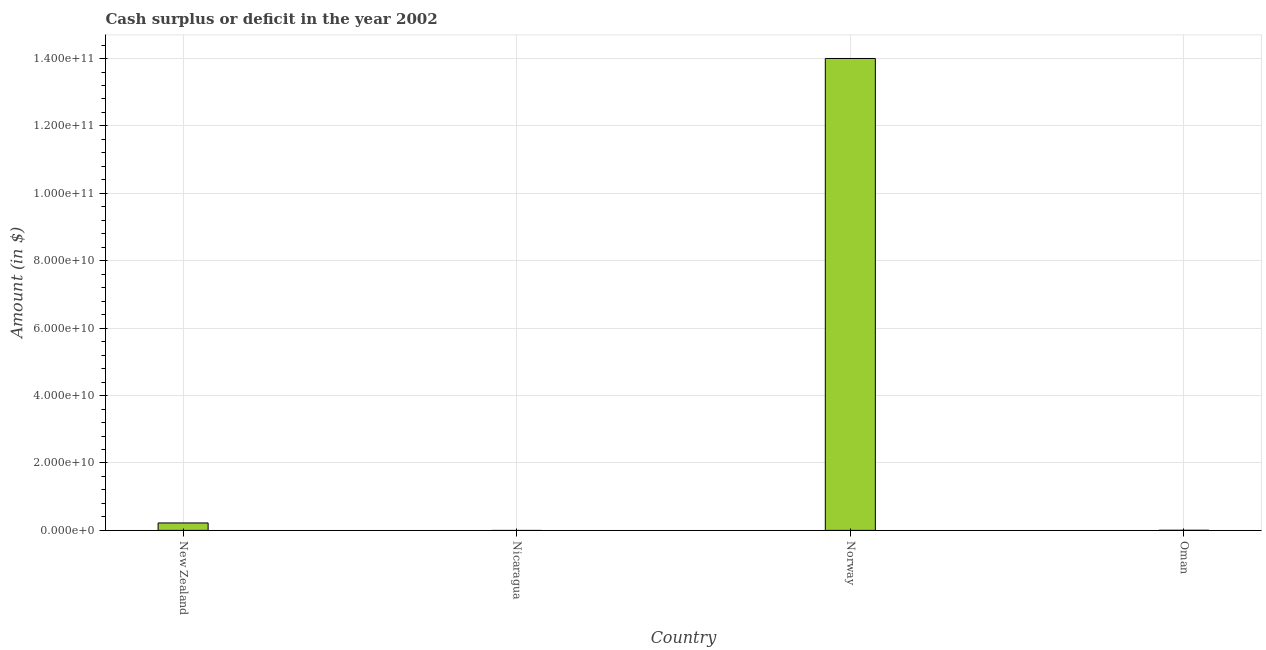Does the graph contain any zero values?
Ensure brevity in your answer.  Yes. Does the graph contain grids?
Keep it short and to the point. Yes. What is the title of the graph?
Provide a short and direct response. Cash surplus or deficit in the year 2002. What is the label or title of the X-axis?
Your response must be concise. Country. What is the label or title of the Y-axis?
Ensure brevity in your answer.  Amount (in $). What is the cash surplus or deficit in New Zealand?
Make the answer very short. 2.20e+09. Across all countries, what is the maximum cash surplus or deficit?
Your answer should be compact. 1.40e+11. What is the sum of the cash surplus or deficit?
Give a very brief answer. 1.42e+11. What is the difference between the cash surplus or deficit in New Zealand and Oman?
Make the answer very short. 2.17e+09. What is the average cash surplus or deficit per country?
Provide a succinct answer. 3.56e+1. What is the median cash surplus or deficit?
Your response must be concise. 1.12e+09. What is the ratio of the cash surplus or deficit in New Zealand to that in Oman?
Ensure brevity in your answer.  72.24. Is the cash surplus or deficit in New Zealand less than that in Norway?
Your answer should be compact. Yes. What is the difference between the highest and the second highest cash surplus or deficit?
Offer a terse response. 1.38e+11. What is the difference between the highest and the lowest cash surplus or deficit?
Offer a terse response. 1.40e+11. How many bars are there?
Offer a very short reply. 3. How many countries are there in the graph?
Offer a very short reply. 4. Are the values on the major ticks of Y-axis written in scientific E-notation?
Give a very brief answer. Yes. What is the Amount (in $) in New Zealand?
Offer a terse response. 2.20e+09. What is the Amount (in $) of Nicaragua?
Offer a very short reply. 0. What is the Amount (in $) of Norway?
Your answer should be compact. 1.40e+11. What is the Amount (in $) in Oman?
Provide a short and direct response. 3.05e+07. What is the difference between the Amount (in $) in New Zealand and Norway?
Your response must be concise. -1.38e+11. What is the difference between the Amount (in $) in New Zealand and Oman?
Give a very brief answer. 2.17e+09. What is the difference between the Amount (in $) in Norway and Oman?
Make the answer very short. 1.40e+11. What is the ratio of the Amount (in $) in New Zealand to that in Norway?
Make the answer very short. 0.02. What is the ratio of the Amount (in $) in New Zealand to that in Oman?
Your response must be concise. 72.24. What is the ratio of the Amount (in $) in Norway to that in Oman?
Ensure brevity in your answer.  4590.62. 